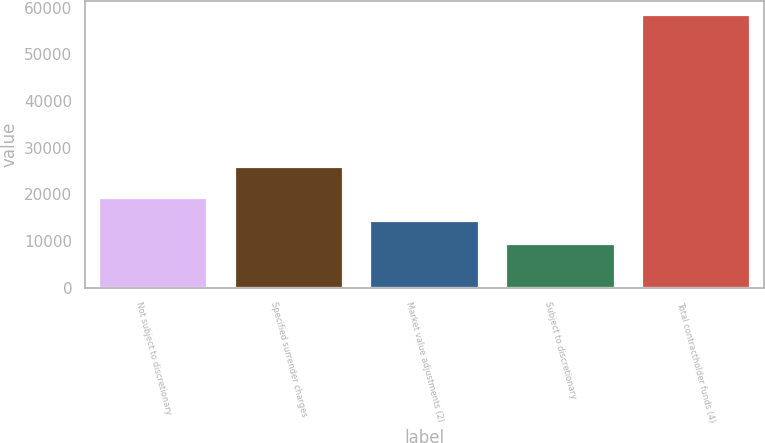<chart> <loc_0><loc_0><loc_500><loc_500><bar_chart><fcel>Not subject to discretionary<fcel>Specified surrender charges<fcel>Market value adjustments (2)<fcel>Subject to discretionary<fcel>Total contractholder funds (4)<nl><fcel>19236.2<fcel>25781<fcel>14339.1<fcel>9442<fcel>58413<nl></chart> 